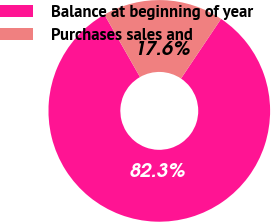Convert chart. <chart><loc_0><loc_0><loc_500><loc_500><pie_chart><fcel>Balance at beginning of year<fcel>Purchases sales and<nl><fcel>82.35%<fcel>17.65%<nl></chart> 